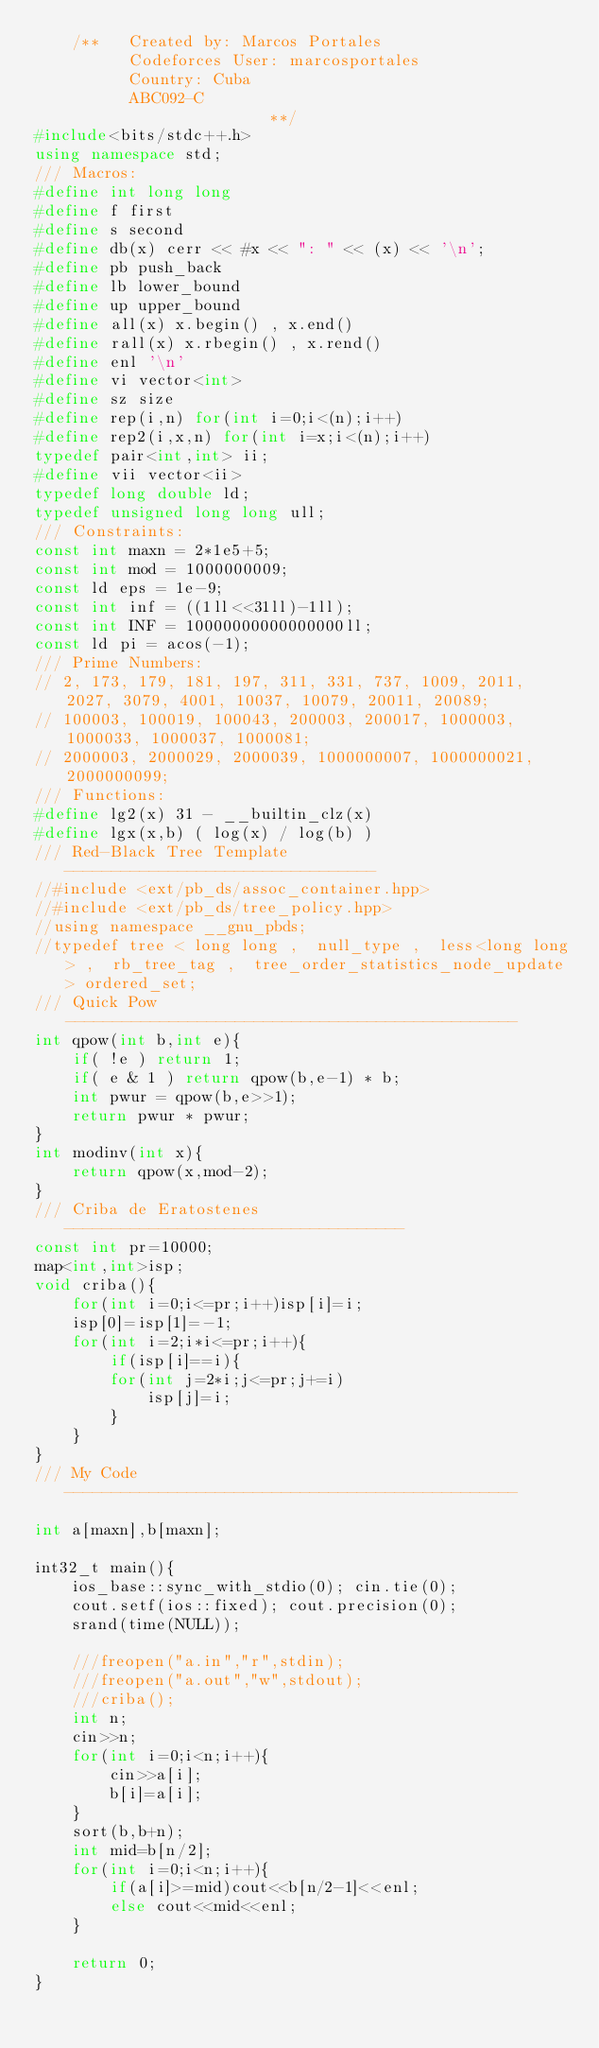<code> <loc_0><loc_0><loc_500><loc_500><_C++_>    /**   Created by: Marcos Portales
          Codeforces User: marcosportales
          Country: Cuba
          ABC092-C
                         **/
#include<bits/stdc++.h>
using namespace std;
/// Macros:
#define int long long
#define f first
#define s second
#define db(x) cerr << #x << ": " << (x) << '\n';
#define pb push_back
#define lb lower_bound
#define up upper_bound
#define all(x) x.begin() , x.end()
#define rall(x) x.rbegin() , x.rend()
#define enl '\n'
#define vi vector<int>
#define sz size
#define rep(i,n) for(int i=0;i<(n);i++)
#define rep2(i,x,n) for(int i=x;i<(n);i++)
typedef pair<int,int> ii;
#define vii vector<ii>
typedef long double ld;
typedef unsigned long long ull;
/// Constraints:
const int maxn = 2*1e5+5;
const int mod = 1000000009;
const ld eps = 1e-9;
const int inf = ((1ll<<31ll)-1ll);
const int INF = 10000000000000000ll;
const ld pi = acos(-1);
/// Prime Numbers:
// 2, 173, 179, 181, 197, 311, 331, 737, 1009, 2011, 2027, 3079, 4001, 10037, 10079, 20011, 20089;
// 100003, 100019, 100043, 200003, 200017, 1000003, 1000033, 1000037, 1000081;
// 2000003, 2000029, 2000039, 1000000007, 1000000021, 2000000099;
/// Functions:
#define lg2(x) 31 - __builtin_clz(x)
#define lgx(x,b) ( log(x) / log(b) )
/// Red-Black Tree Template ---------------------------------
//#include <ext/pb_ds/assoc_container.hpp>
//#include <ext/pb_ds/tree_policy.hpp>
//using namespace __gnu_pbds;
//typedef tree < long long ,  null_type ,  less<long long> ,  rb_tree_tag ,  tree_order_statistics_node_update > ordered_set;
/// Quick Pow------------------------------------------------
int qpow(int b,int e){
    if( !e ) return 1;
    if( e & 1 ) return qpow(b,e-1) * b;
    int pwur = qpow(b,e>>1);
    return pwur * pwur;
}
int modinv(int x){
    return qpow(x,mod-2);
}
/// Criba de Eratostenes ------------------------------------
const int pr=10000;
map<int,int>isp;
void criba(){
    for(int i=0;i<=pr;i++)isp[i]=i;
    isp[0]=isp[1]=-1;
    for(int i=2;i*i<=pr;i++){
        if(isp[i]==i){
        for(int j=2*i;j<=pr;j+=i)
            isp[j]=i;
        }
    }
}
/// My Code ------------------------------------------------

int a[maxn],b[maxn];

int32_t main(){
    ios_base::sync_with_stdio(0); cin.tie(0);
    cout.setf(ios::fixed); cout.precision(0);
    srand(time(NULL));

    ///freopen("a.in","r",stdin);
    ///freopen("a.out","w",stdout);
    ///criba();
    int n;
    cin>>n;
    for(int i=0;i<n;i++){
        cin>>a[i];
        b[i]=a[i];
    }
    sort(b,b+n);
    int mid=b[n/2];
    for(int i=0;i<n;i++){
        if(a[i]>=mid)cout<<b[n/2-1]<<enl;
        else cout<<mid<<enl;
    }

    return 0;
}
</code> 